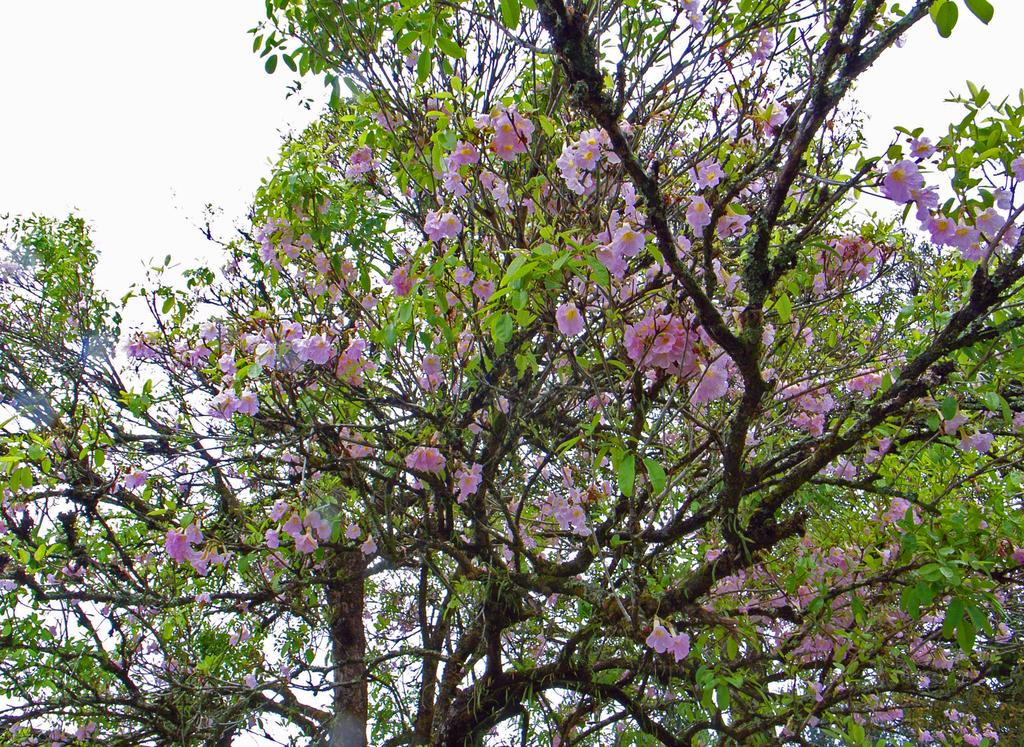What type of plant can be seen in the picture? There is a tree in the picture. What other natural elements are present in the image? There are flowers in the picture. How would you describe the weather based on the sky in the picture? The sky is cloudy in the picture. What type of sugar is being used to sweeten the sleet in the image? There is no sleet or sugar present in the image; it features a tree and flowers with a cloudy sky. 